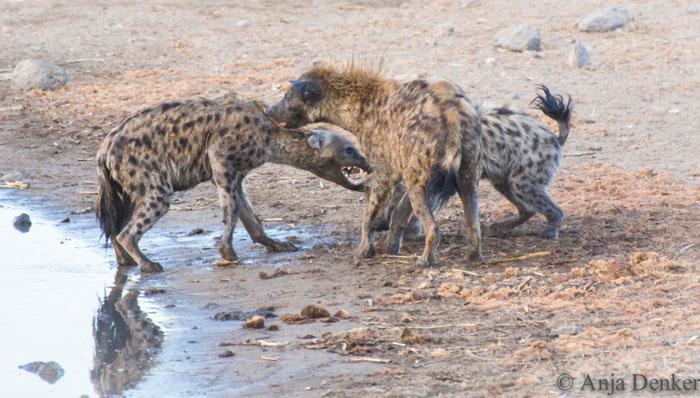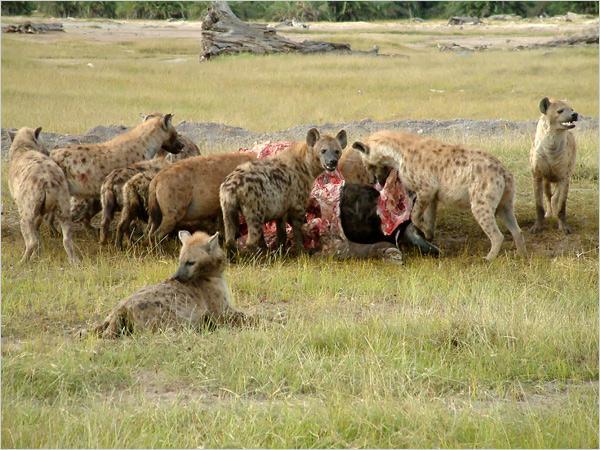The first image is the image on the left, the second image is the image on the right. Examine the images to the left and right. Is the description "There are hyenas feasting on a dead animal." accurate? Answer yes or no. Yes. The first image is the image on the left, the second image is the image on the right. Analyze the images presented: Is the assertion "The right image includes at least one jackal near at least two spotted hyenas." valid? Answer yes or no. No. 